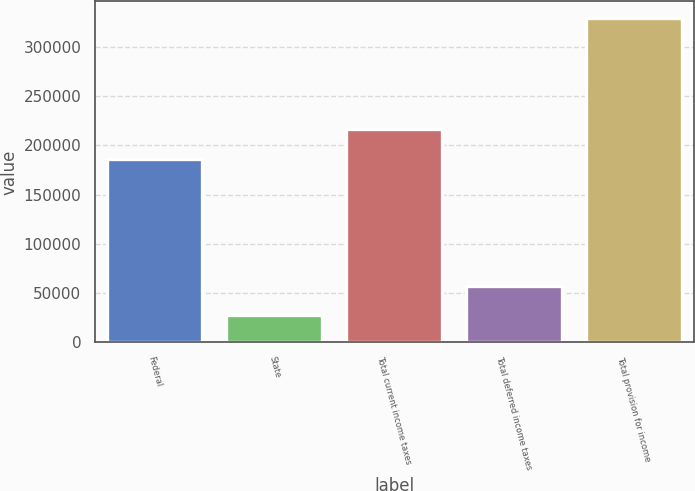Convert chart to OTSL. <chart><loc_0><loc_0><loc_500><loc_500><bar_chart><fcel>Federal<fcel>State<fcel>Total current income taxes<fcel>Total deferred income taxes<fcel>Total provision for income<nl><fcel>186486<fcel>27589<fcel>216672<fcel>57774.8<fcel>329447<nl></chart> 